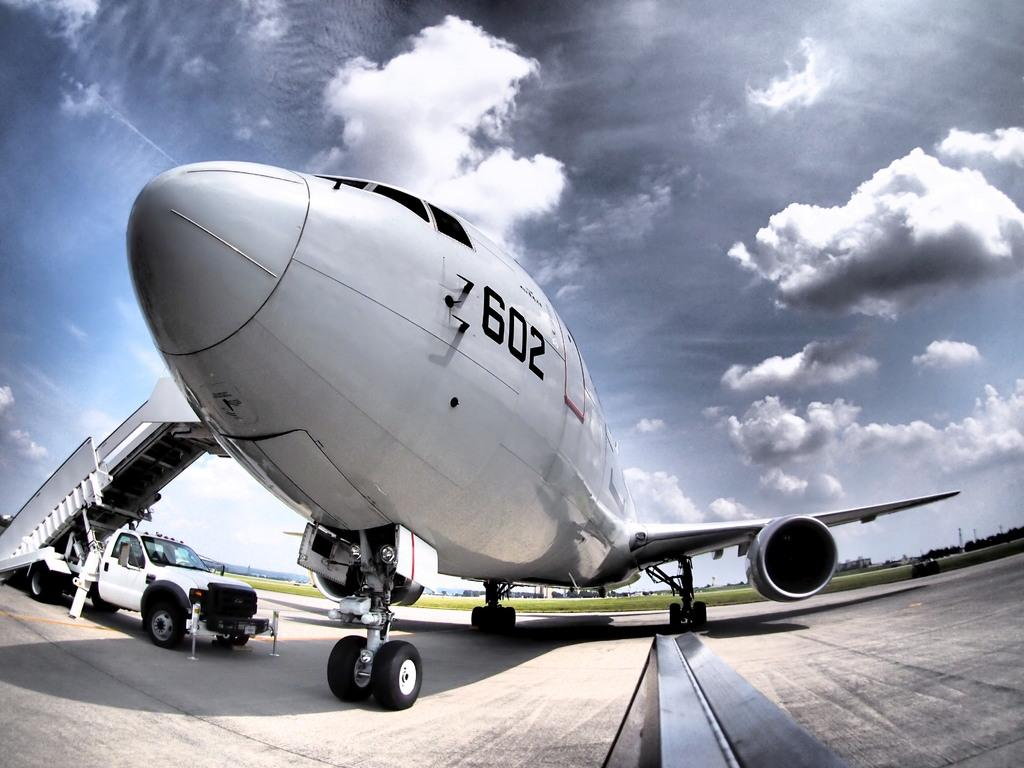Provide a one-sentence caption for the provided image. Plane number 602 is preparing for loading at the airport. 